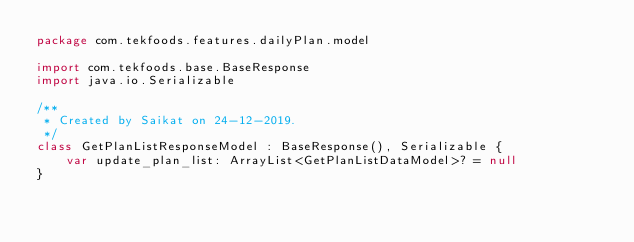Convert code to text. <code><loc_0><loc_0><loc_500><loc_500><_Kotlin_>package com.tekfoods.features.dailyPlan.model

import com.tekfoods.base.BaseResponse
import java.io.Serializable

/**
 * Created by Saikat on 24-12-2019.
 */
class GetPlanListResponseModel : BaseResponse(), Serializable {
    var update_plan_list: ArrayList<GetPlanListDataModel>? = null
}</code> 